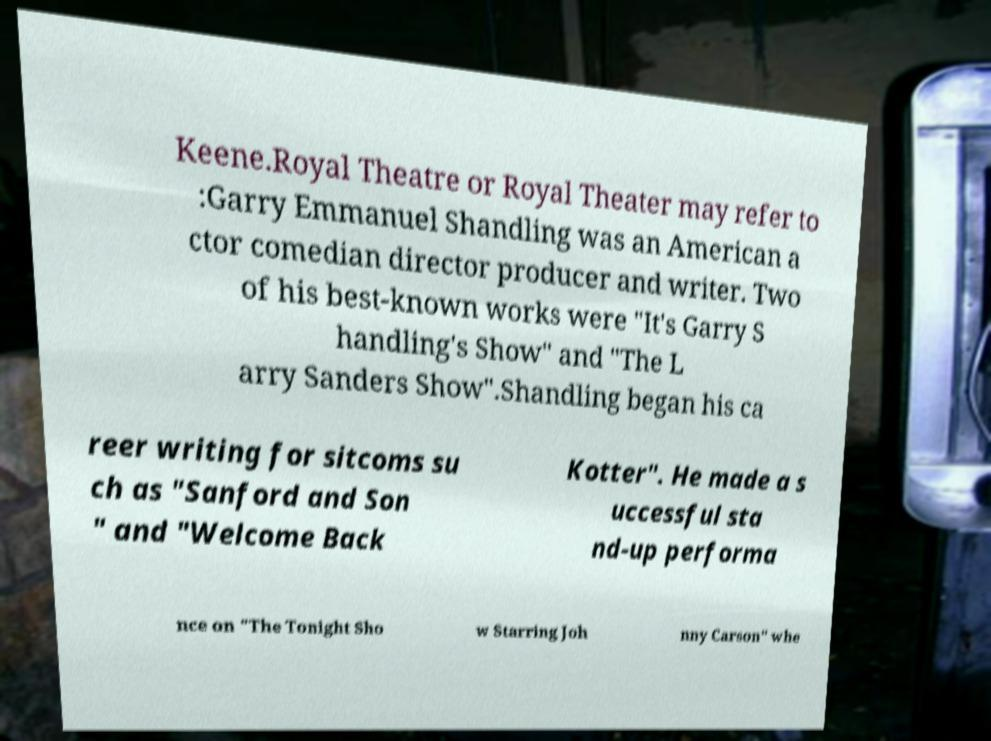Can you read and provide the text displayed in the image?This photo seems to have some interesting text. Can you extract and type it out for me? Keene.Royal Theatre or Royal Theater may refer to :Garry Emmanuel Shandling was an American a ctor comedian director producer and writer. Two of his best-known works were "It's Garry S handling's Show" and "The L arry Sanders Show".Shandling began his ca reer writing for sitcoms su ch as "Sanford and Son " and "Welcome Back Kotter". He made a s uccessful sta nd-up performa nce on "The Tonight Sho w Starring Joh nny Carson" whe 